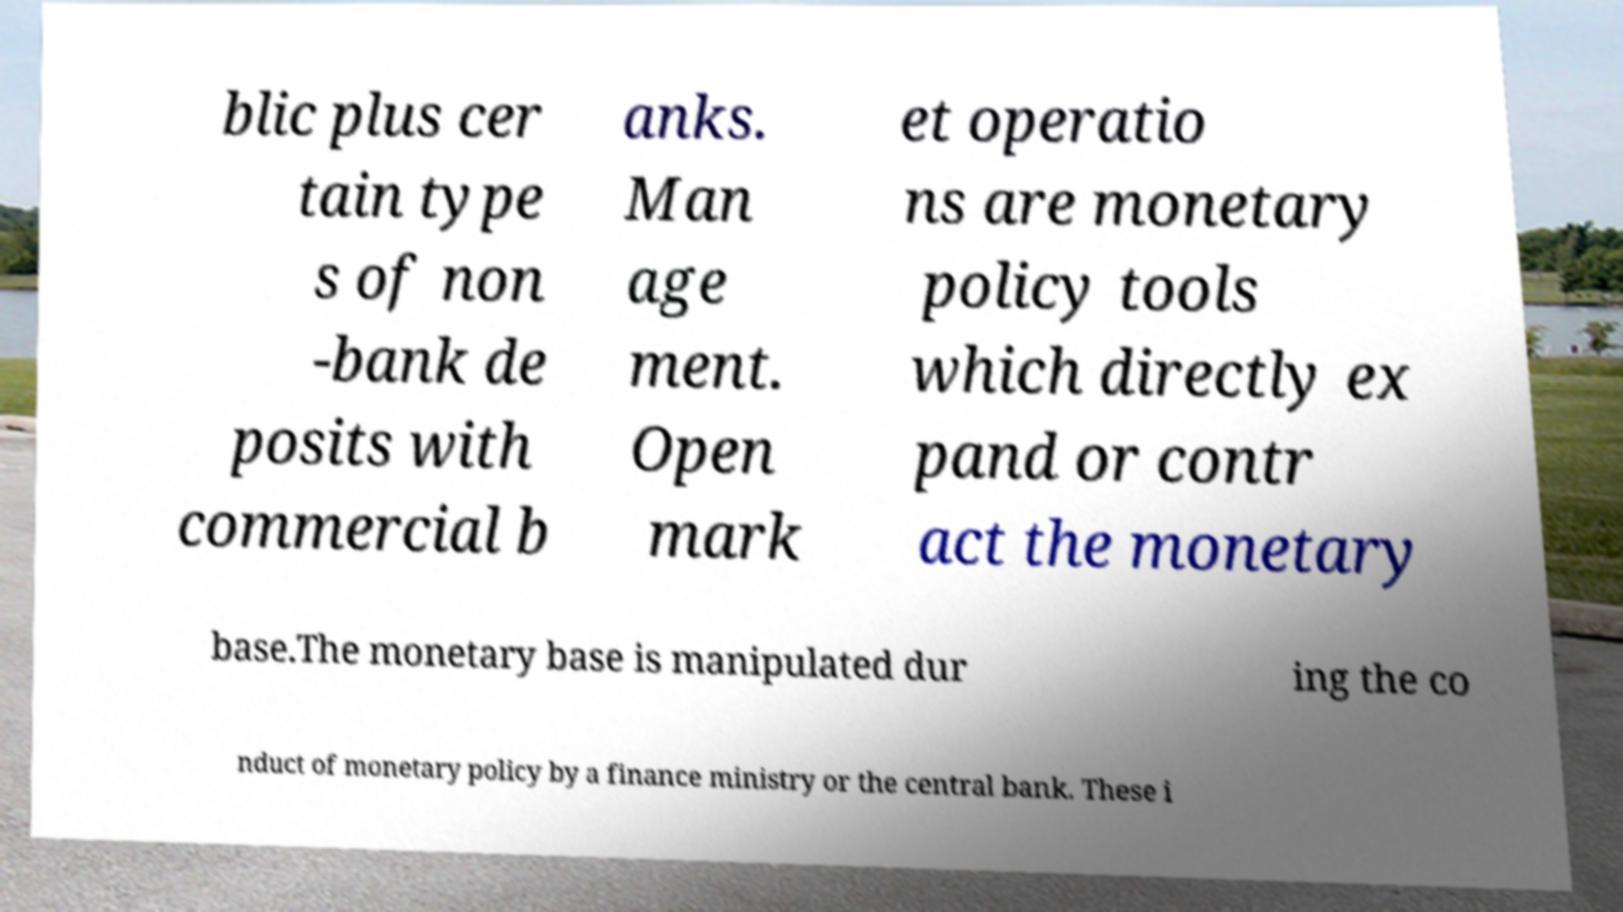Please identify and transcribe the text found in this image. blic plus cer tain type s of non -bank de posits with commercial b anks. Man age ment. Open mark et operatio ns are monetary policy tools which directly ex pand or contr act the monetary base.The monetary base is manipulated dur ing the co nduct of monetary policy by a finance ministry or the central bank. These i 